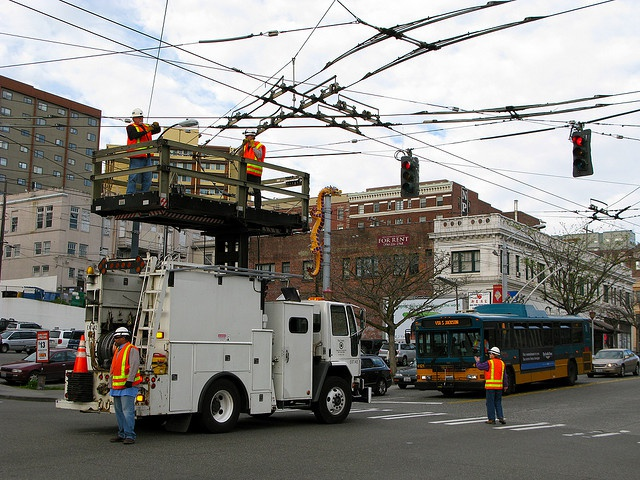Describe the objects in this image and their specific colors. I can see truck in white, darkgray, black, and gray tones, bus in white, black, maroon, blue, and darkblue tones, people in white, black, gray, red, and blue tones, car in white, black, gray, and darkgray tones, and people in white, black, darkblue, blue, and maroon tones in this image. 